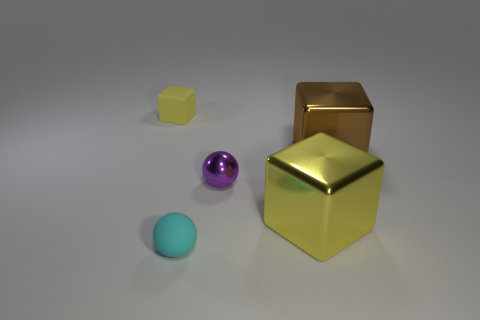Are there any other big metallic things of the same shape as the large brown object?
Provide a short and direct response. Yes. There is a brown thing that is the same size as the yellow metal thing; what shape is it?
Provide a short and direct response. Cube. Is the number of objects that are in front of the tiny purple metallic sphere the same as the number of small cyan matte balls that are in front of the rubber sphere?
Ensure brevity in your answer.  No. How big is the object in front of the big metal object that is in front of the big brown metallic cube?
Your answer should be very brief. Small. Are there any yellow things of the same size as the brown object?
Make the answer very short. Yes. The tiny cube that is made of the same material as the cyan object is what color?
Offer a terse response. Yellow. Is the number of large brown blocks less than the number of brown shiny balls?
Give a very brief answer. No. There is a object that is both on the right side of the tiny purple shiny ball and in front of the tiny purple metallic sphere; what is its material?
Make the answer very short. Metal. Are there any yellow blocks that are in front of the metal cube that is behind the tiny metal thing?
Give a very brief answer. Yes. What number of other tiny rubber blocks are the same color as the small rubber block?
Provide a succinct answer. 0. 